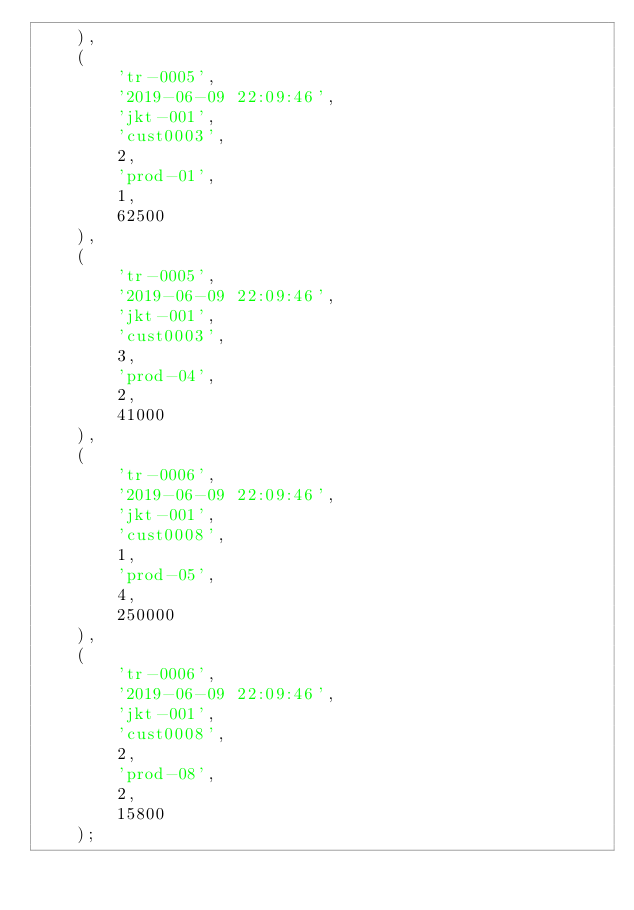<code> <loc_0><loc_0><loc_500><loc_500><_SQL_>    ),
    (
        'tr-0005',
        '2019-06-09 22:09:46',
        'jkt-001',
        'cust0003',
        2,
        'prod-01',
        1,
        62500
    ),
    (
        'tr-0005',
        '2019-06-09 22:09:46',
        'jkt-001',
        'cust0003',
        3,
        'prod-04',
        2,
        41000
    ),
    (
        'tr-0006',
        '2019-06-09 22:09:46',
        'jkt-001',
        'cust0008',
        1,
        'prod-05',
        4,
        250000
    ),
    (
        'tr-0006',
        '2019-06-09 22:09:46',
        'jkt-001',
        'cust0008',
        2,
        'prod-08',
        2,
        15800
    );</code> 